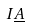<formula> <loc_0><loc_0><loc_500><loc_500>I \underline { A }</formula> 